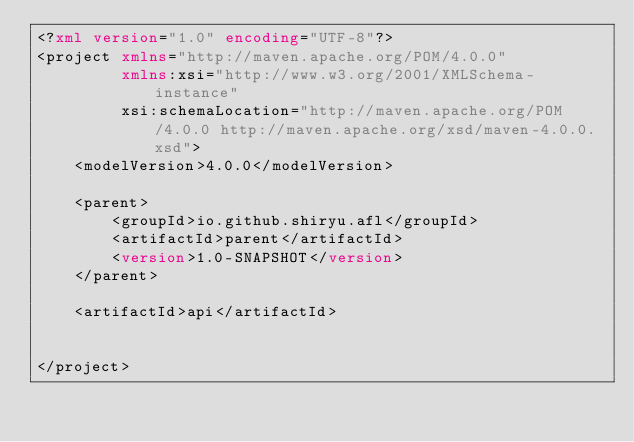Convert code to text. <code><loc_0><loc_0><loc_500><loc_500><_XML_><?xml version="1.0" encoding="UTF-8"?>
<project xmlns="http://maven.apache.org/POM/4.0.0"
         xmlns:xsi="http://www.w3.org/2001/XMLSchema-instance"
         xsi:schemaLocation="http://maven.apache.org/POM/4.0.0 http://maven.apache.org/xsd/maven-4.0.0.xsd">
    <modelVersion>4.0.0</modelVersion>

    <parent>
        <groupId>io.github.shiryu.afl</groupId>
        <artifactId>parent</artifactId>
        <version>1.0-SNAPSHOT</version>
    </parent>

    <artifactId>api</artifactId>


</project></code> 